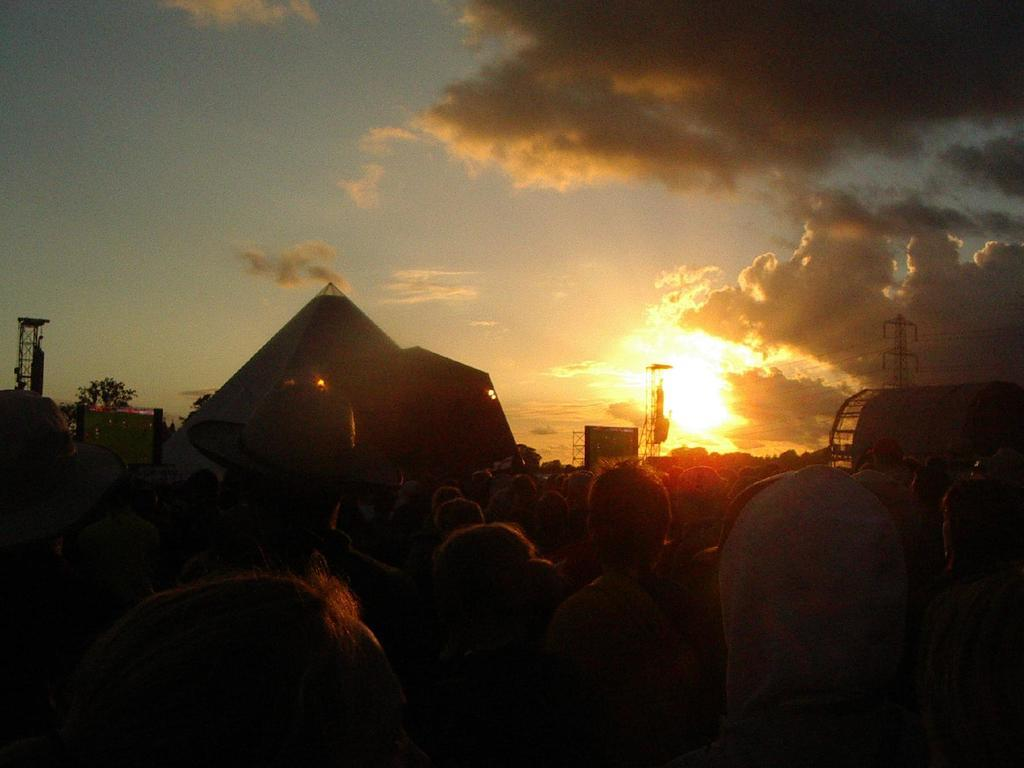What is the main subject of the image? The main subject of the image is a group of people. What can be seen in the background of the image? There are electric poles and plants in the background of the image. What is the color of the sky in the image? The sky is blue and white in color. Can you describe the lighting in the image? Sunlight is visible in the image. What type of vest is the person in the image wearing? There is no vest visible in the image. What type of market can be seen in the background of the image? There is no market present in the image; it features a group of people, electric poles, plants, and a blue and white sky. 